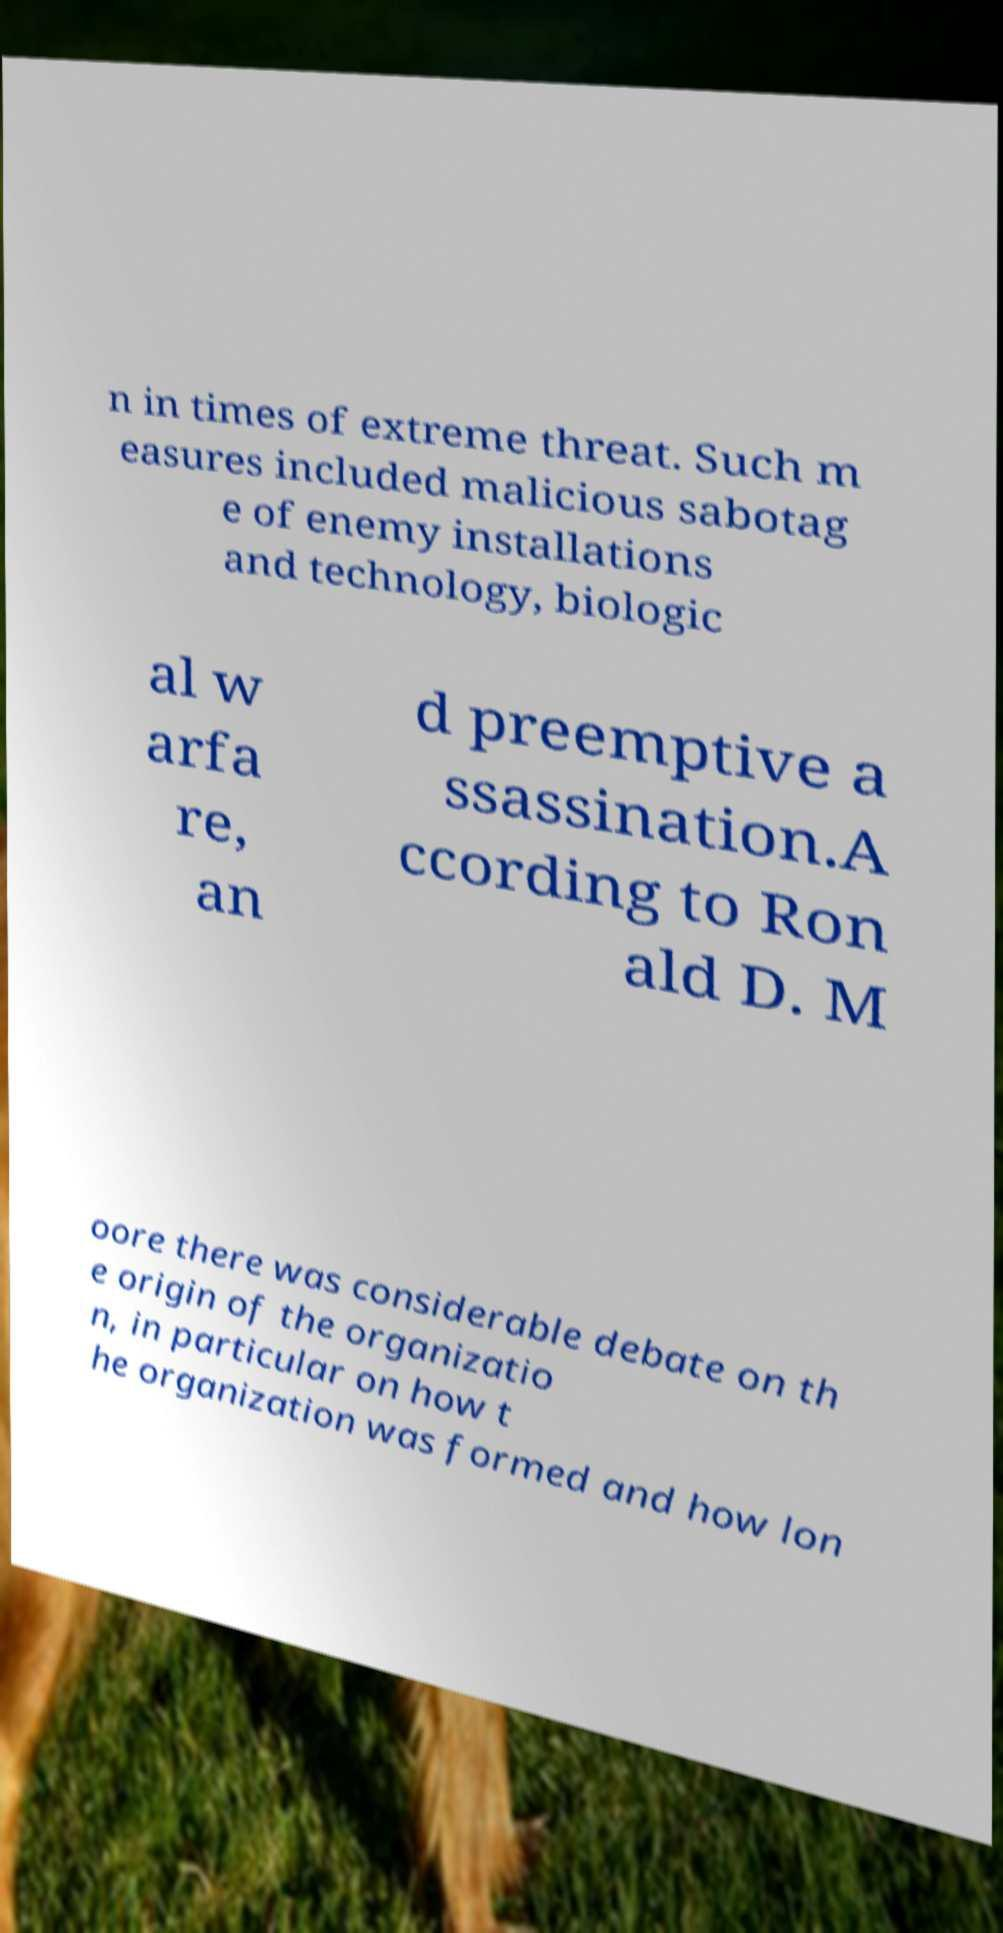What messages or text are displayed in this image? I need them in a readable, typed format. n in times of extreme threat. Such m easures included malicious sabotag e of enemy installations and technology, biologic al w arfa re, an d preemptive a ssassination.A ccording to Ron ald D. M oore there was considerable debate on th e origin of the organizatio n, in particular on how t he organization was formed and how lon 